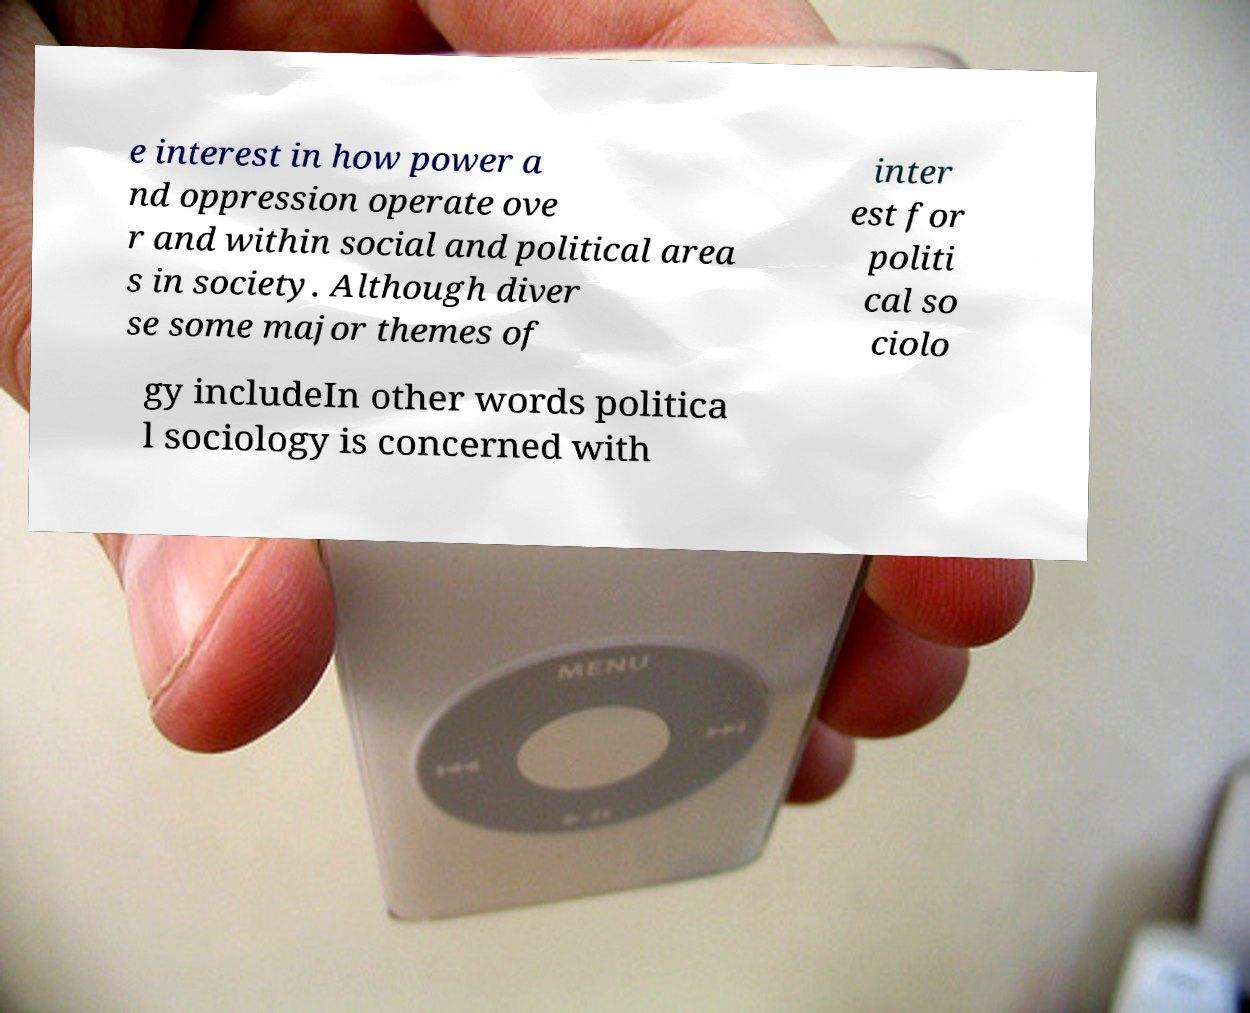For documentation purposes, I need the text within this image transcribed. Could you provide that? e interest in how power a nd oppression operate ove r and within social and political area s in society. Although diver se some major themes of inter est for politi cal so ciolo gy includeIn other words politica l sociology is concerned with 